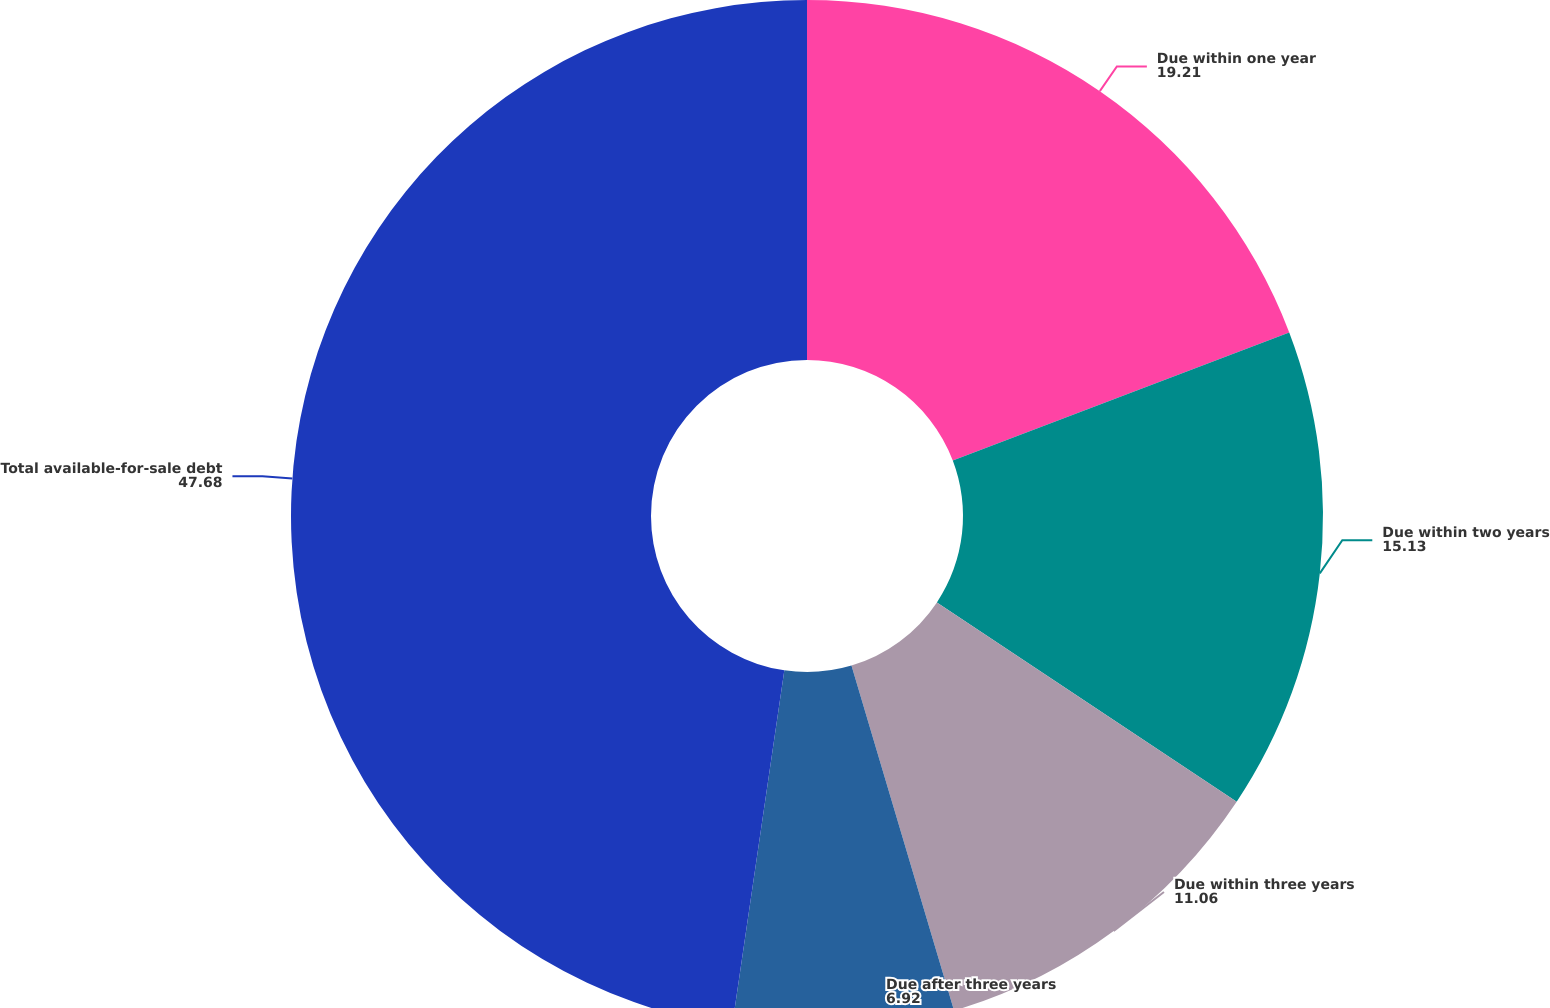<chart> <loc_0><loc_0><loc_500><loc_500><pie_chart><fcel>Due within one year<fcel>Due within two years<fcel>Due within three years<fcel>Due after three years<fcel>Total available-for-sale debt<nl><fcel>19.21%<fcel>15.13%<fcel>11.06%<fcel>6.92%<fcel>47.68%<nl></chart> 